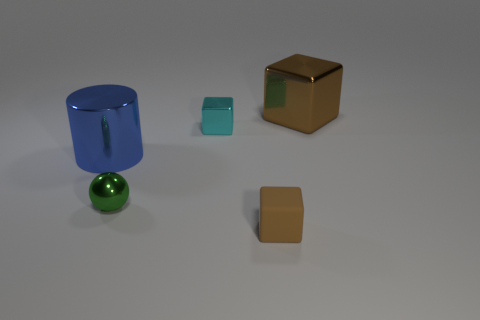What is the material of the small thing that is the same color as the large shiny cube?
Ensure brevity in your answer.  Rubber. Are there any other things that are the same shape as the big brown shiny thing?
Your answer should be very brief. Yes. There is a brown shiny object; does it have the same shape as the big metal thing in front of the small metal block?
Your answer should be very brief. No. How many other things are there of the same material as the tiny brown cube?
Give a very brief answer. 0. Do the big metal cube and the tiny cube in front of the cyan metallic block have the same color?
Give a very brief answer. Yes. What is the small green thing that is in front of the large brown thing made of?
Your answer should be very brief. Metal. Is there a rubber thing of the same color as the big block?
Keep it short and to the point. Yes. The sphere that is the same size as the matte block is what color?
Give a very brief answer. Green. What number of big objects are either yellow shiny balls or blue cylinders?
Keep it short and to the point. 1. Are there an equal number of large brown metallic cubes left of the cyan metallic cube and small objects behind the small green shiny ball?
Your response must be concise. No. 